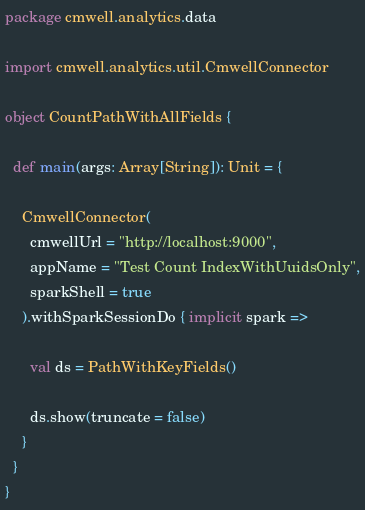<code> <loc_0><loc_0><loc_500><loc_500><_Scala_>package cmwell.analytics.data

import cmwell.analytics.util.CmwellConnector

object CountPathWithAllFields {

  def main(args: Array[String]): Unit = {

    CmwellConnector(
      cmwellUrl = "http://localhost:9000",
      appName = "Test Count IndexWithUuidsOnly",
      sparkShell = true
    ).withSparkSessionDo { implicit spark =>

      val ds = PathWithKeyFields()

      ds.show(truncate = false)
    }
  }
}
</code> 